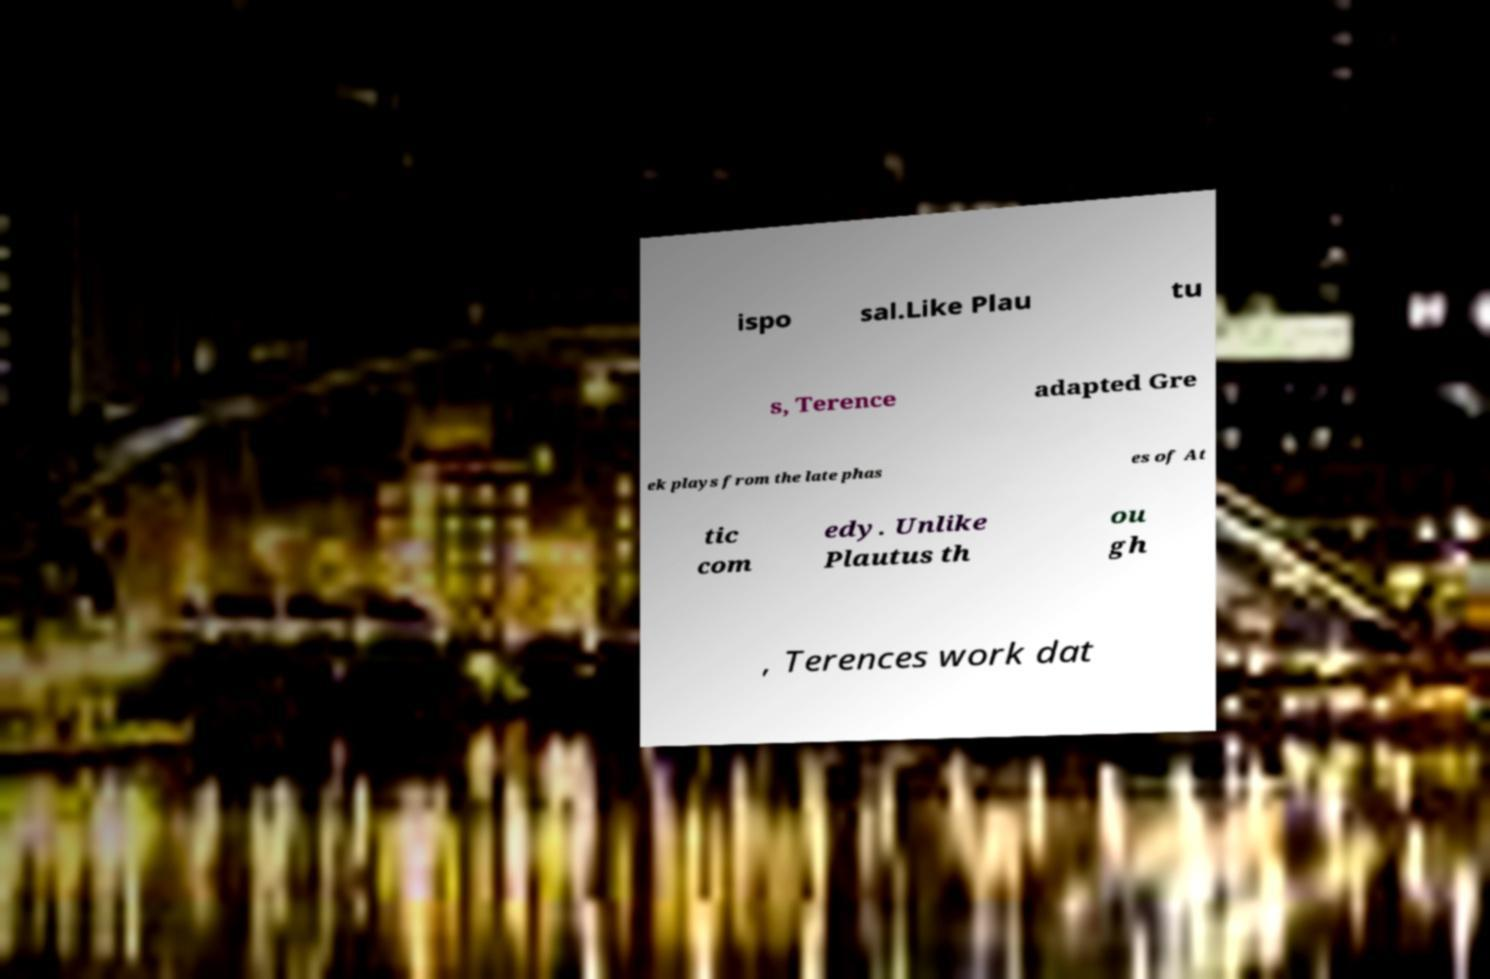Can you accurately transcribe the text from the provided image for me? ispo sal.Like Plau tu s, Terence adapted Gre ek plays from the late phas es of At tic com edy. Unlike Plautus th ou gh , Terences work dat 